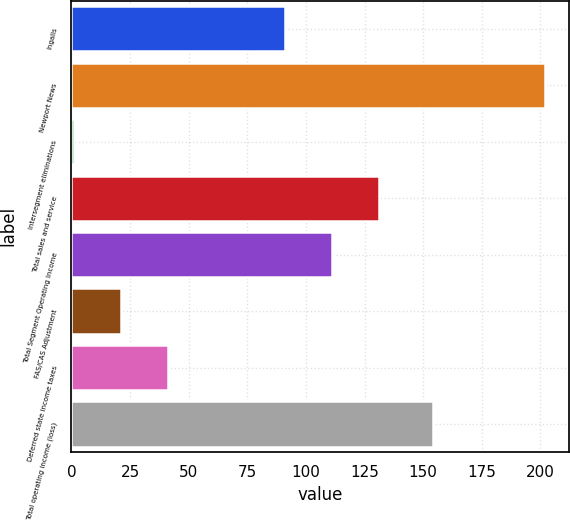Convert chart. <chart><loc_0><loc_0><loc_500><loc_500><bar_chart><fcel>Ingalls<fcel>Newport News<fcel>Intersegment eliminations<fcel>Total sales and service<fcel>Total Segment Operating Income<fcel>FAS/CAS Adjustment<fcel>Deferred state income taxes<fcel>Total operating income (loss)<nl><fcel>91<fcel>202<fcel>1<fcel>131.2<fcel>111.1<fcel>21.1<fcel>41.2<fcel>154<nl></chart> 